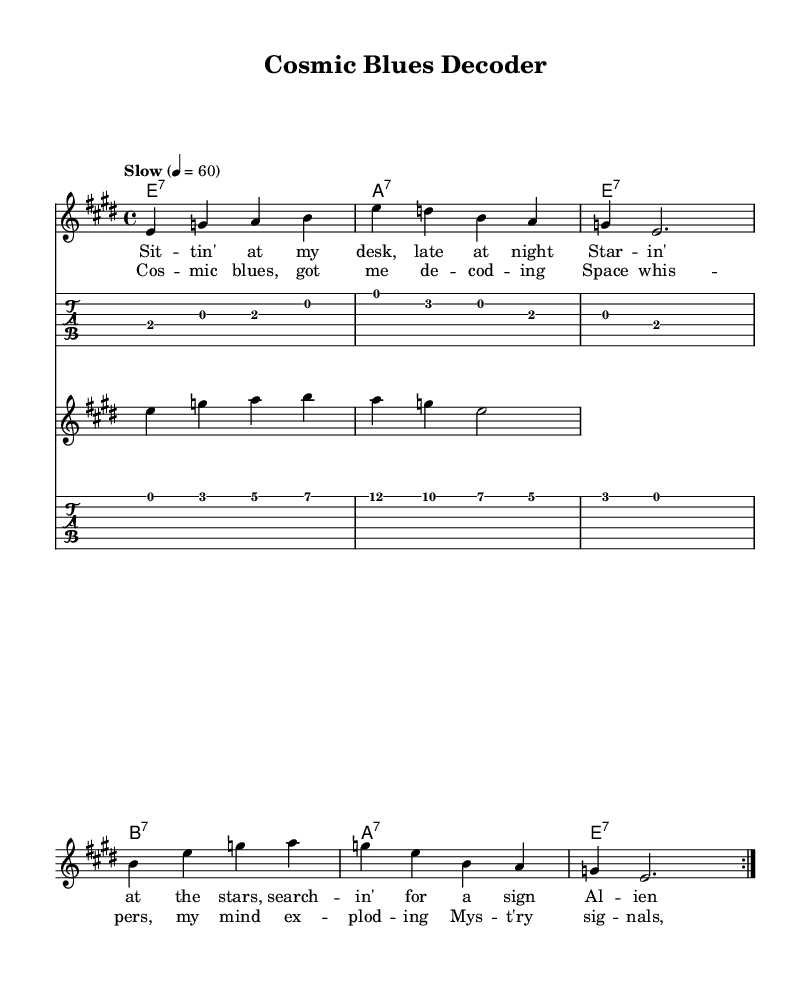What is the key signature of this music? The key signature indicated at the beginning of the score shows that it is E major, which has four sharps (F#, C#, G#, and D#).
Answer: E major What is the time signature of this music? The time signature is found at the beginning of the score, indicating 4/4 time, which means there are four beats in a measure.
Answer: 4/4 What is the tempo marking of this piece? The tempo marking at the start of the score describes the piece as "Slow" with a metronome marking of 60 beats per minute.
Answer: Slow 4 = 60 How many measures are in the chorus section? By counting the number of measures in the chorus lyrics, each line of the chorus corresponds to a measure. There are four measures in total in the chorus section.
Answer: 4 Which chord appears most frequently in the harmony? Analyzing the chord progression reveals that E7 appears repeatedly, as it is the first chord in the sequence and is used multiple times throughout the piece.
Answer: E7 What scale is predominantly used in the melody? The melody primarily uses notes from the E major scale, which includes E, F#, G#, A, B, C#, and D#. This scale supports the bluesy feel of the piece.
Answer: E major What is the structure of the song? Observing the layout, the structure consists of alternating verses and choruses, typical of blues music, where a verse is followed by a chorus and then repeated sections.
Answer: Verse-Chorus 